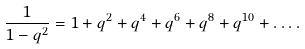Convert formula to latex. <formula><loc_0><loc_0><loc_500><loc_500>\frac { 1 } { 1 - q ^ { 2 } } = 1 + q ^ { 2 } + q ^ { 4 } + q ^ { 6 } + q ^ { 8 } + q ^ { 1 0 } + \dots .</formula> 